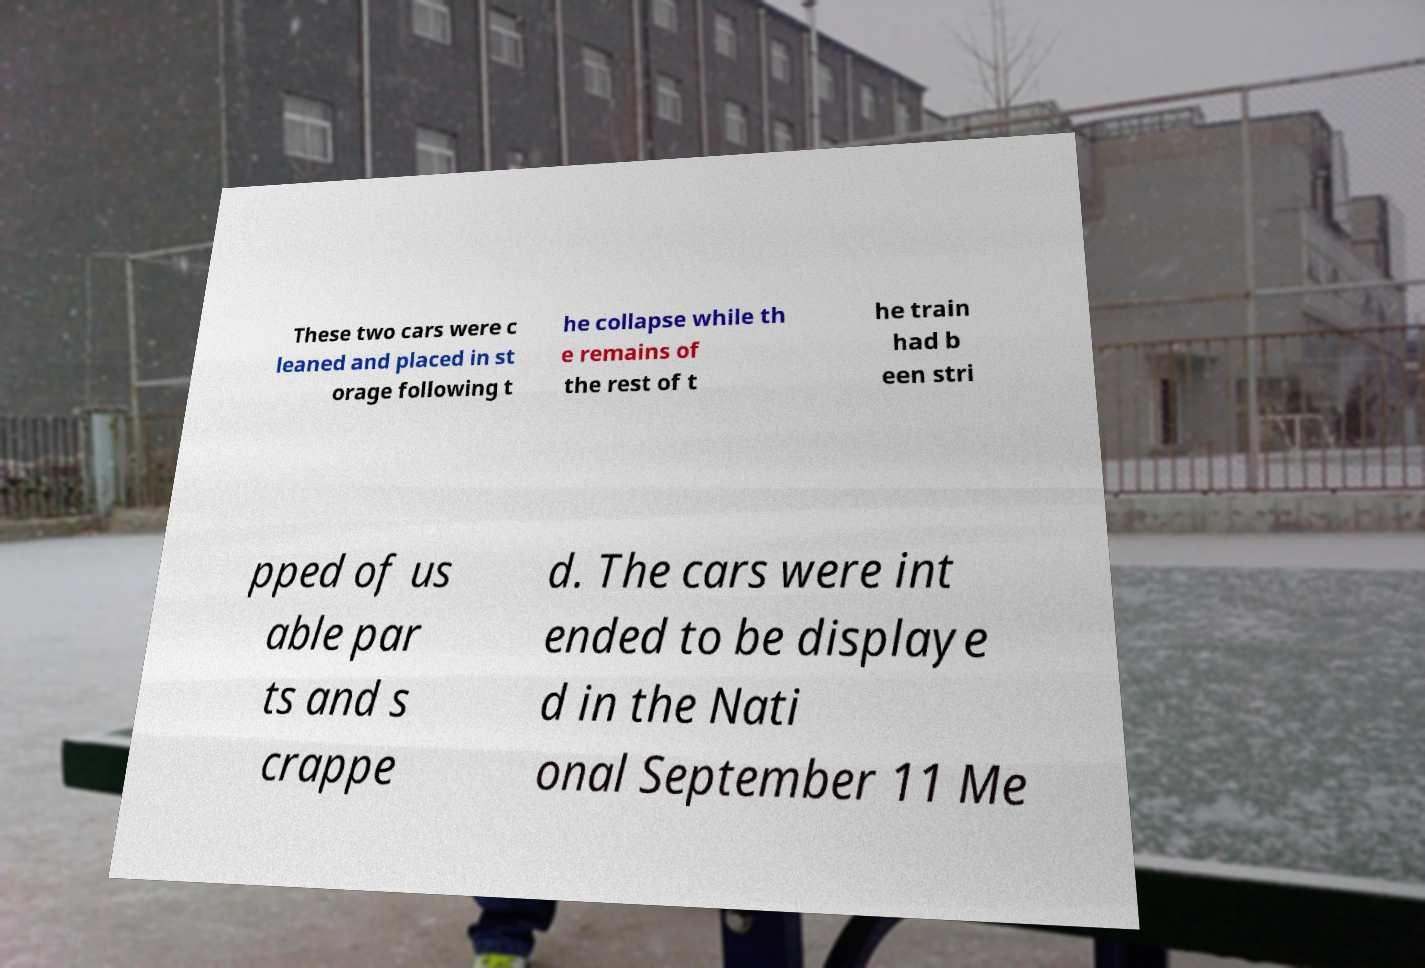Please read and relay the text visible in this image. What does it say? These two cars were c leaned and placed in st orage following t he collapse while th e remains of the rest of t he train had b een stri pped of us able par ts and s crappe d. The cars were int ended to be displaye d in the Nati onal September 11 Me 